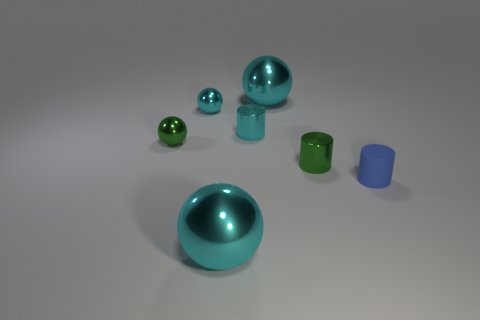What number of tiny rubber objects have the same color as the small rubber cylinder?
Give a very brief answer. 0. What number of things are cyan metallic spheres that are in front of the tiny rubber cylinder or cyan cylinders?
Provide a short and direct response. 2. There is a cyan ball that is in front of the cyan metal cylinder; how big is it?
Keep it short and to the point. Large. Is the number of tiny cyan shiny cylinders less than the number of large red matte cylinders?
Give a very brief answer. No. Does the thing in front of the rubber cylinder have the same material as the blue thing that is in front of the small green sphere?
Make the answer very short. No. The green metallic thing to the left of the large sphere that is behind the cyan object that is in front of the blue matte thing is what shape?
Provide a short and direct response. Sphere. What number of tiny green cylinders have the same material as the cyan cylinder?
Give a very brief answer. 1. How many cyan shiny cylinders are in front of the big sphere in front of the tiny blue cylinder?
Offer a very short reply. 0. There is a big metal thing behind the blue cylinder; is it the same color as the big shiny ball in front of the blue object?
Offer a terse response. Yes. What shape is the cyan thing that is to the left of the cyan cylinder and behind the blue matte thing?
Your response must be concise. Sphere. 